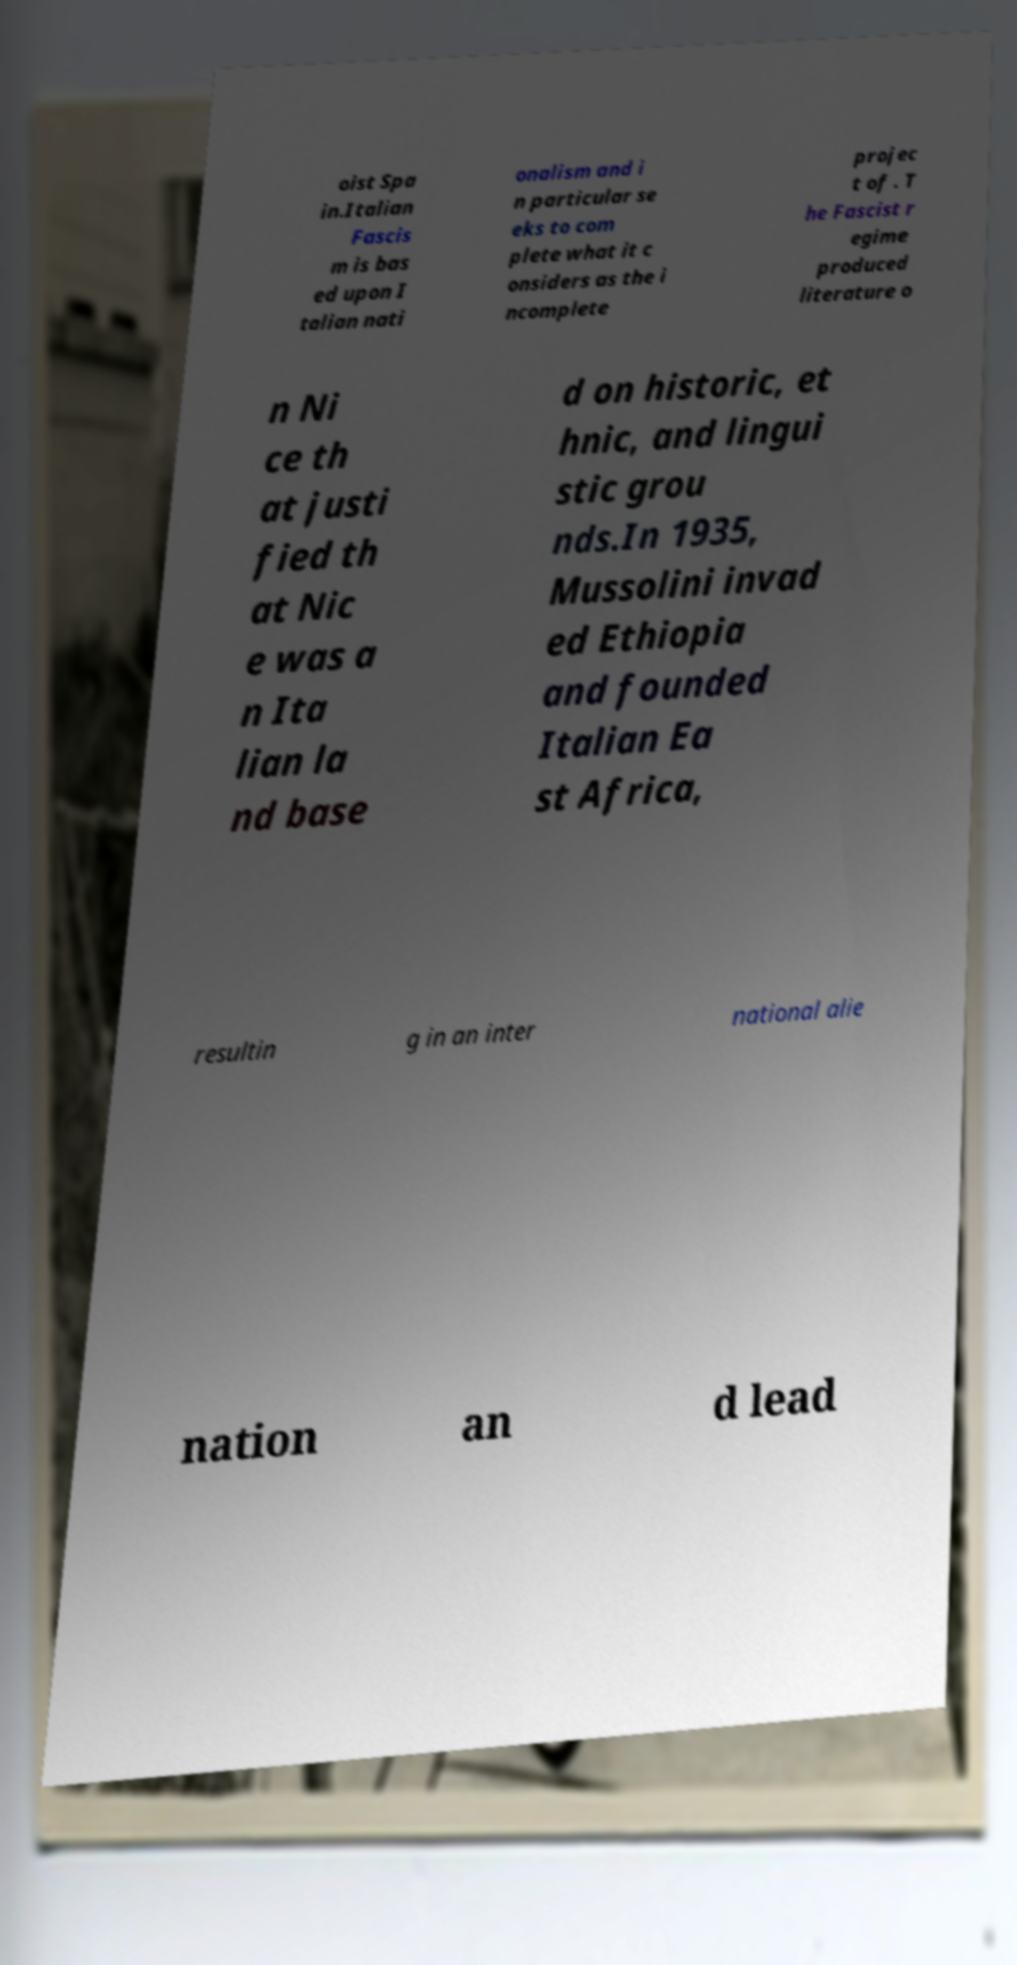Could you extract and type out the text from this image? oist Spa in.Italian Fascis m is bas ed upon I talian nati onalism and i n particular se eks to com plete what it c onsiders as the i ncomplete projec t of . T he Fascist r egime produced literature o n Ni ce th at justi fied th at Nic e was a n Ita lian la nd base d on historic, et hnic, and lingui stic grou nds.In 1935, Mussolini invad ed Ethiopia and founded Italian Ea st Africa, resultin g in an inter national alie nation an d lead 